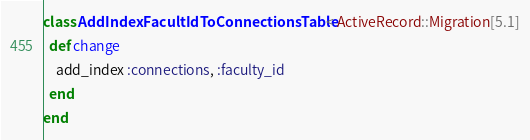Convert code to text. <code><loc_0><loc_0><loc_500><loc_500><_Ruby_>class AddIndexFacultIdToConnectionsTable < ActiveRecord::Migration[5.1]
  def change
    add_index :connections, :faculty_id 
  end
end
</code> 